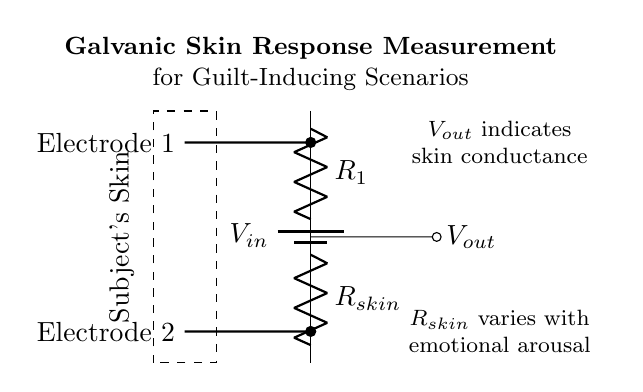What is the input voltage in this circuit? The input voltage is denoted as **V_in** in the circuit diagram, which is the voltage provided by the battery.
Answer: V_in What does V_out represent in the circuit? V_out indicates the output voltage, which is taken across the resistor R_skin and reflects the skin conductance based on emotional arousal.
Answer: Output voltage What are the names of the two resistors in the voltage divider? The two resistors in the diagram are labeled as R_1 and R_skin, with R_1 being the top resistor and R_skin being the bottom resistor connected to the subject's skin.
Answer: R_1 and R_skin How does R_skin change with emotional arousal? R_skin varies based on the emotional state of the subject. When a person experiences guilt, it influences their skin conductivity, which in turn changes the resistance value of R_skin.
Answer: It varies What is the purpose of the voltage divider in this context? The voltage divider's role is to measure the galvanic skin response, which involves quantifying the electrical conductivity of the skin as a reaction to guilt-inducing scenarios, helping in understanding emotional responses.
Answer: Measure galvanic skin response What does the dashed rectangle represent in the circuit diagram? The dashed rectangle represents the subject's skin, highlighting the area of interest where the galvanic skin response is being measured through the electrodes connected to R_skin.
Answer: Subject's skin 